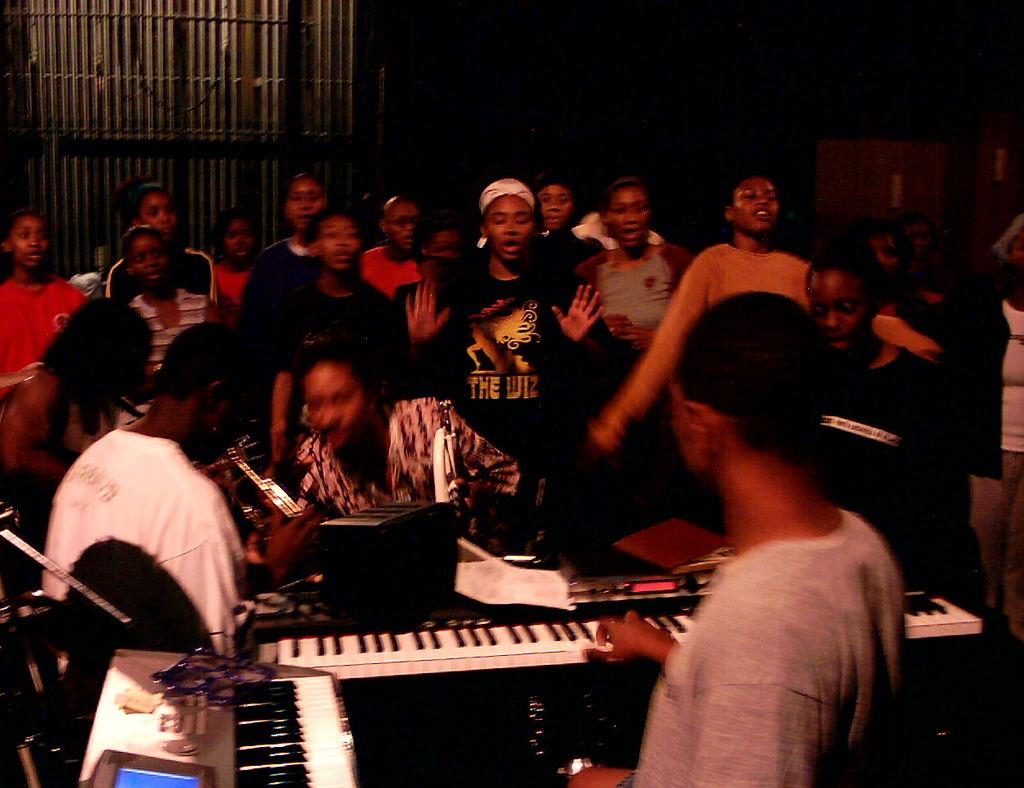What are the people in the image doing? There are people sitting and standing in the image. What objects can be seen in the front of the image? There are blue and white color musical keyboards in the front of the image. What type of root vegetable is being used as a glue to hold the people together in the image? There is no root vegetable or glue present in the image; the people are not physically connected to each other. 